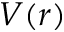Convert formula to latex. <formula><loc_0><loc_0><loc_500><loc_500>V ( r )</formula> 